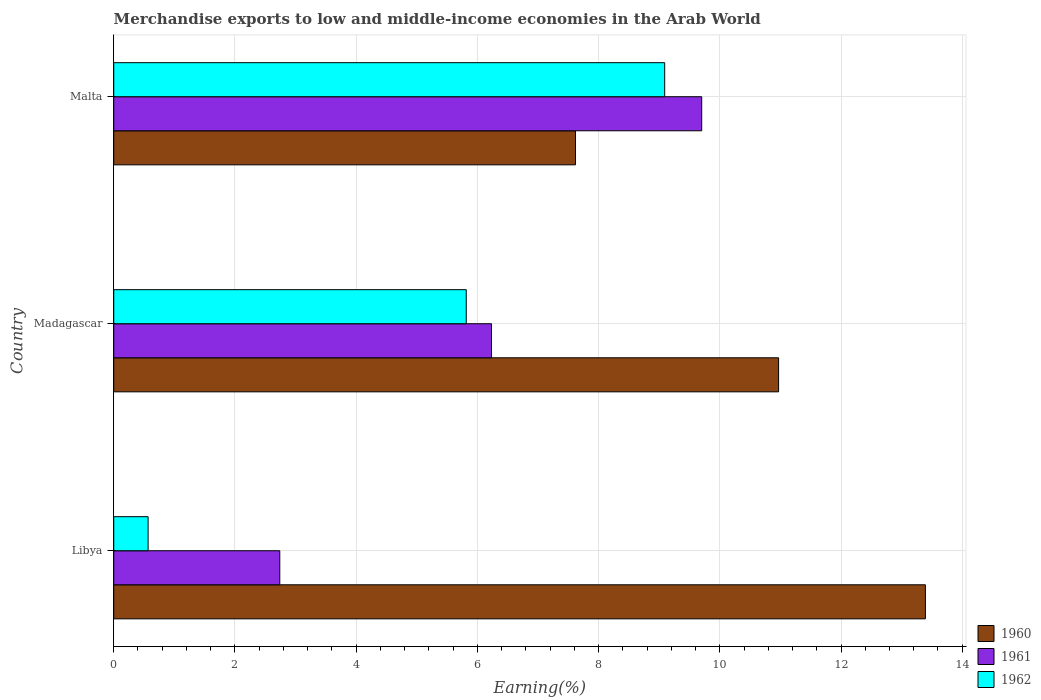How many different coloured bars are there?
Your answer should be compact. 3. How many groups of bars are there?
Offer a terse response. 3. How many bars are there on the 3rd tick from the top?
Your answer should be very brief. 3. What is the label of the 3rd group of bars from the top?
Give a very brief answer. Libya. What is the percentage of amount earned from merchandise exports in 1961 in Malta?
Provide a succinct answer. 9.7. Across all countries, what is the maximum percentage of amount earned from merchandise exports in 1962?
Keep it short and to the point. 9.09. Across all countries, what is the minimum percentage of amount earned from merchandise exports in 1961?
Ensure brevity in your answer.  2.74. In which country was the percentage of amount earned from merchandise exports in 1961 maximum?
Your response must be concise. Malta. In which country was the percentage of amount earned from merchandise exports in 1962 minimum?
Your response must be concise. Libya. What is the total percentage of amount earned from merchandise exports in 1960 in the graph?
Keep it short and to the point. 31.98. What is the difference between the percentage of amount earned from merchandise exports in 1960 in Madagascar and that in Malta?
Provide a short and direct response. 3.35. What is the difference between the percentage of amount earned from merchandise exports in 1961 in Malta and the percentage of amount earned from merchandise exports in 1962 in Madagascar?
Ensure brevity in your answer.  3.88. What is the average percentage of amount earned from merchandise exports in 1960 per country?
Offer a terse response. 10.66. What is the difference between the percentage of amount earned from merchandise exports in 1962 and percentage of amount earned from merchandise exports in 1960 in Malta?
Your response must be concise. 1.47. In how many countries, is the percentage of amount earned from merchandise exports in 1962 greater than 1.2000000000000002 %?
Provide a short and direct response. 2. What is the ratio of the percentage of amount earned from merchandise exports in 1960 in Madagascar to that in Malta?
Keep it short and to the point. 1.44. What is the difference between the highest and the second highest percentage of amount earned from merchandise exports in 1962?
Make the answer very short. 3.27. What is the difference between the highest and the lowest percentage of amount earned from merchandise exports in 1962?
Provide a short and direct response. 8.52. In how many countries, is the percentage of amount earned from merchandise exports in 1962 greater than the average percentage of amount earned from merchandise exports in 1962 taken over all countries?
Make the answer very short. 2. What does the 1st bar from the top in Malta represents?
Provide a succinct answer. 1962. How many bars are there?
Your response must be concise. 9. What is the difference between two consecutive major ticks on the X-axis?
Your response must be concise. 2. Are the values on the major ticks of X-axis written in scientific E-notation?
Provide a short and direct response. No. Where does the legend appear in the graph?
Give a very brief answer. Bottom right. What is the title of the graph?
Ensure brevity in your answer.  Merchandise exports to low and middle-income economies in the Arab World. Does "1988" appear as one of the legend labels in the graph?
Your answer should be compact. No. What is the label or title of the X-axis?
Give a very brief answer. Earning(%). What is the label or title of the Y-axis?
Provide a short and direct response. Country. What is the Earning(%) of 1960 in Libya?
Offer a very short reply. 13.39. What is the Earning(%) in 1961 in Libya?
Your answer should be compact. 2.74. What is the Earning(%) in 1962 in Libya?
Your answer should be compact. 0.57. What is the Earning(%) in 1960 in Madagascar?
Your response must be concise. 10.97. What is the Earning(%) of 1961 in Madagascar?
Offer a terse response. 6.23. What is the Earning(%) in 1962 in Madagascar?
Offer a terse response. 5.82. What is the Earning(%) in 1960 in Malta?
Ensure brevity in your answer.  7.62. What is the Earning(%) of 1961 in Malta?
Your answer should be very brief. 9.7. What is the Earning(%) of 1962 in Malta?
Your answer should be very brief. 9.09. Across all countries, what is the maximum Earning(%) in 1960?
Keep it short and to the point. 13.39. Across all countries, what is the maximum Earning(%) in 1961?
Provide a succinct answer. 9.7. Across all countries, what is the maximum Earning(%) in 1962?
Your answer should be compact. 9.09. Across all countries, what is the minimum Earning(%) in 1960?
Your response must be concise. 7.62. Across all countries, what is the minimum Earning(%) of 1961?
Offer a very short reply. 2.74. Across all countries, what is the minimum Earning(%) of 1962?
Your answer should be compact. 0.57. What is the total Earning(%) in 1960 in the graph?
Give a very brief answer. 31.98. What is the total Earning(%) of 1961 in the graph?
Ensure brevity in your answer.  18.67. What is the total Earning(%) of 1962 in the graph?
Give a very brief answer. 15.47. What is the difference between the Earning(%) of 1960 in Libya and that in Madagascar?
Make the answer very short. 2.42. What is the difference between the Earning(%) in 1961 in Libya and that in Madagascar?
Offer a terse response. -3.49. What is the difference between the Earning(%) of 1962 in Libya and that in Madagascar?
Offer a very short reply. -5.25. What is the difference between the Earning(%) in 1960 in Libya and that in Malta?
Your answer should be compact. 5.77. What is the difference between the Earning(%) of 1961 in Libya and that in Malta?
Your response must be concise. -6.96. What is the difference between the Earning(%) in 1962 in Libya and that in Malta?
Ensure brevity in your answer.  -8.52. What is the difference between the Earning(%) of 1960 in Madagascar and that in Malta?
Give a very brief answer. 3.35. What is the difference between the Earning(%) in 1961 in Madagascar and that in Malta?
Provide a succinct answer. -3.47. What is the difference between the Earning(%) in 1962 in Madagascar and that in Malta?
Keep it short and to the point. -3.27. What is the difference between the Earning(%) of 1960 in Libya and the Earning(%) of 1961 in Madagascar?
Provide a succinct answer. 7.16. What is the difference between the Earning(%) of 1960 in Libya and the Earning(%) of 1962 in Madagascar?
Provide a short and direct response. 7.58. What is the difference between the Earning(%) in 1961 in Libya and the Earning(%) in 1962 in Madagascar?
Provide a short and direct response. -3.08. What is the difference between the Earning(%) in 1960 in Libya and the Earning(%) in 1961 in Malta?
Offer a very short reply. 3.69. What is the difference between the Earning(%) in 1960 in Libya and the Earning(%) in 1962 in Malta?
Provide a succinct answer. 4.3. What is the difference between the Earning(%) of 1961 in Libya and the Earning(%) of 1962 in Malta?
Your response must be concise. -6.35. What is the difference between the Earning(%) in 1960 in Madagascar and the Earning(%) in 1961 in Malta?
Your answer should be very brief. 1.27. What is the difference between the Earning(%) of 1960 in Madagascar and the Earning(%) of 1962 in Malta?
Offer a terse response. 1.88. What is the difference between the Earning(%) in 1961 in Madagascar and the Earning(%) in 1962 in Malta?
Make the answer very short. -2.86. What is the average Earning(%) in 1960 per country?
Make the answer very short. 10.66. What is the average Earning(%) of 1961 per country?
Provide a succinct answer. 6.22. What is the average Earning(%) of 1962 per country?
Offer a very short reply. 5.16. What is the difference between the Earning(%) in 1960 and Earning(%) in 1961 in Libya?
Provide a succinct answer. 10.65. What is the difference between the Earning(%) in 1960 and Earning(%) in 1962 in Libya?
Keep it short and to the point. 12.83. What is the difference between the Earning(%) of 1961 and Earning(%) of 1962 in Libya?
Give a very brief answer. 2.17. What is the difference between the Earning(%) of 1960 and Earning(%) of 1961 in Madagascar?
Ensure brevity in your answer.  4.74. What is the difference between the Earning(%) in 1960 and Earning(%) in 1962 in Madagascar?
Offer a very short reply. 5.15. What is the difference between the Earning(%) in 1961 and Earning(%) in 1962 in Madagascar?
Make the answer very short. 0.42. What is the difference between the Earning(%) of 1960 and Earning(%) of 1961 in Malta?
Give a very brief answer. -2.08. What is the difference between the Earning(%) in 1960 and Earning(%) in 1962 in Malta?
Ensure brevity in your answer.  -1.47. What is the difference between the Earning(%) in 1961 and Earning(%) in 1962 in Malta?
Give a very brief answer. 0.61. What is the ratio of the Earning(%) in 1960 in Libya to that in Madagascar?
Make the answer very short. 1.22. What is the ratio of the Earning(%) of 1961 in Libya to that in Madagascar?
Your answer should be very brief. 0.44. What is the ratio of the Earning(%) in 1962 in Libya to that in Madagascar?
Offer a very short reply. 0.1. What is the ratio of the Earning(%) in 1960 in Libya to that in Malta?
Provide a short and direct response. 1.76. What is the ratio of the Earning(%) in 1961 in Libya to that in Malta?
Make the answer very short. 0.28. What is the ratio of the Earning(%) in 1962 in Libya to that in Malta?
Give a very brief answer. 0.06. What is the ratio of the Earning(%) of 1960 in Madagascar to that in Malta?
Ensure brevity in your answer.  1.44. What is the ratio of the Earning(%) of 1961 in Madagascar to that in Malta?
Keep it short and to the point. 0.64. What is the ratio of the Earning(%) in 1962 in Madagascar to that in Malta?
Ensure brevity in your answer.  0.64. What is the difference between the highest and the second highest Earning(%) in 1960?
Offer a terse response. 2.42. What is the difference between the highest and the second highest Earning(%) in 1961?
Your answer should be compact. 3.47. What is the difference between the highest and the second highest Earning(%) of 1962?
Your response must be concise. 3.27. What is the difference between the highest and the lowest Earning(%) of 1960?
Provide a short and direct response. 5.77. What is the difference between the highest and the lowest Earning(%) in 1961?
Ensure brevity in your answer.  6.96. What is the difference between the highest and the lowest Earning(%) in 1962?
Provide a succinct answer. 8.52. 